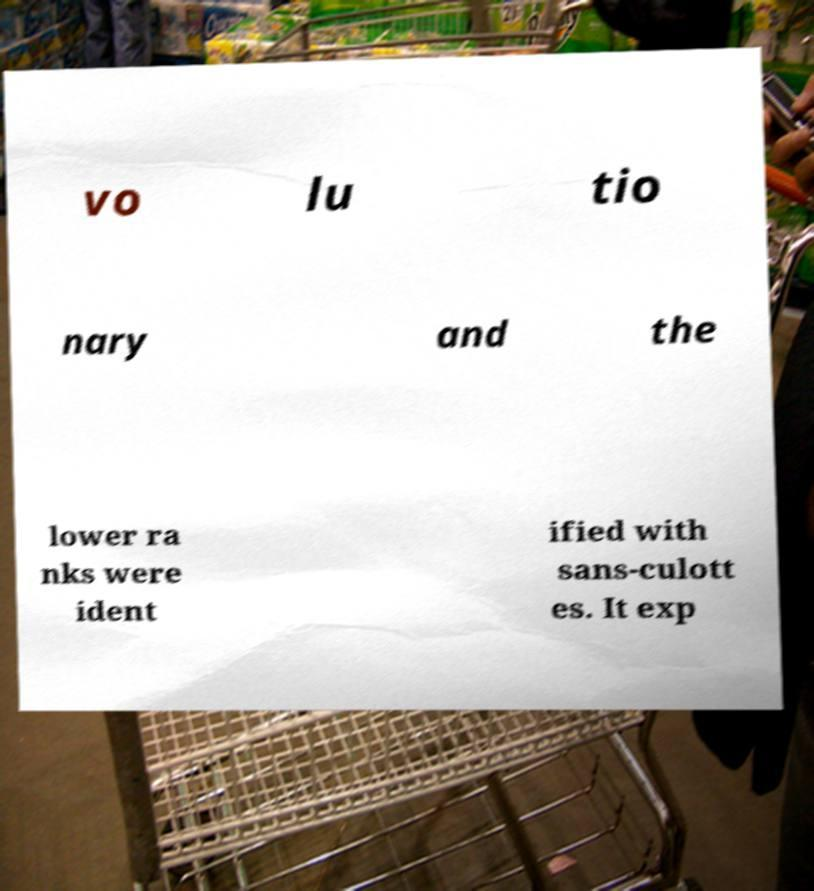Please read and relay the text visible in this image. What does it say? vo lu tio nary and the lower ra nks were ident ified with sans-culott es. It exp 